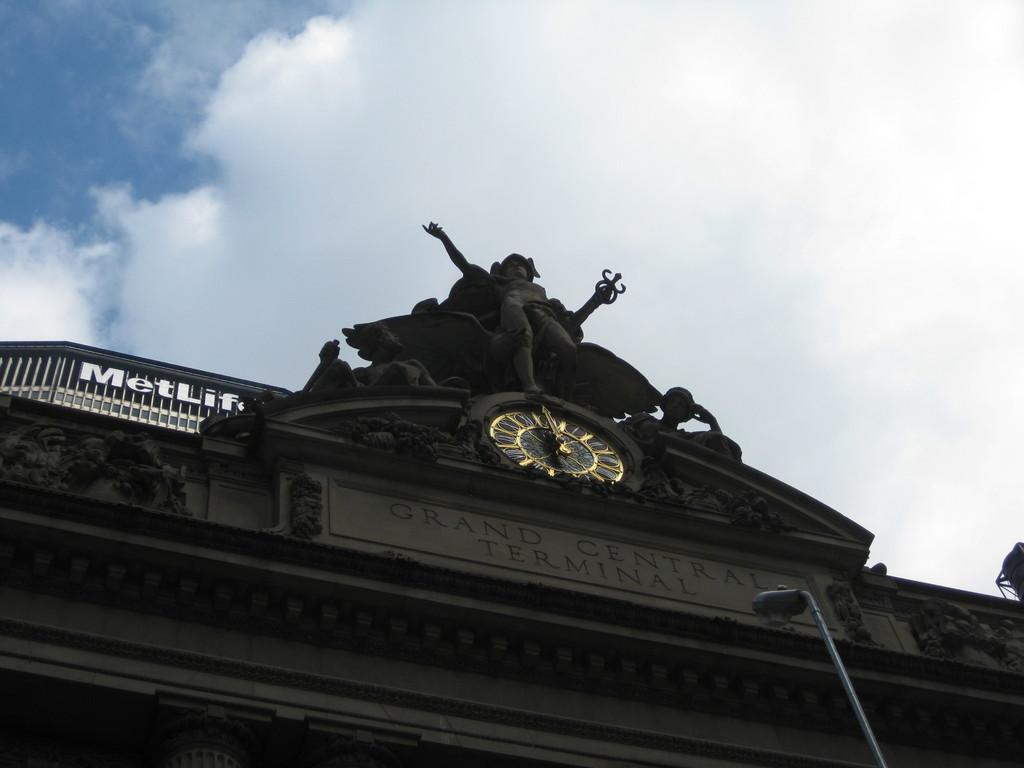<image>
Relay a brief, clear account of the picture shown. A clock and statue are over the sign for Grand Central Terminal. 